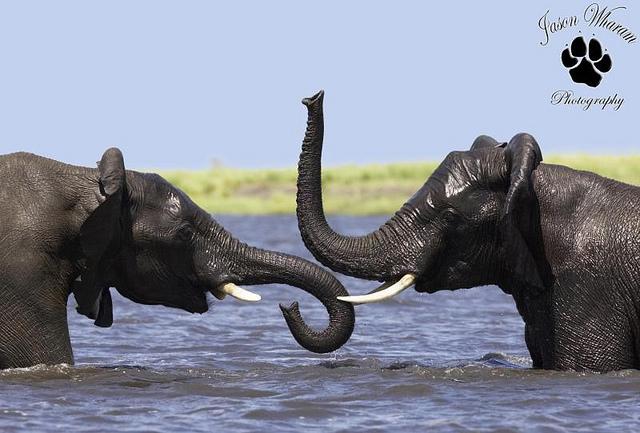Do these elephants like each other?
Keep it brief. Yes. Are the elephants playing?
Write a very short answer. Yes. Which elephant has shorter tusks?
Give a very brief answer. Left. How are the elephants getting wet?
Be succinct. Water. 